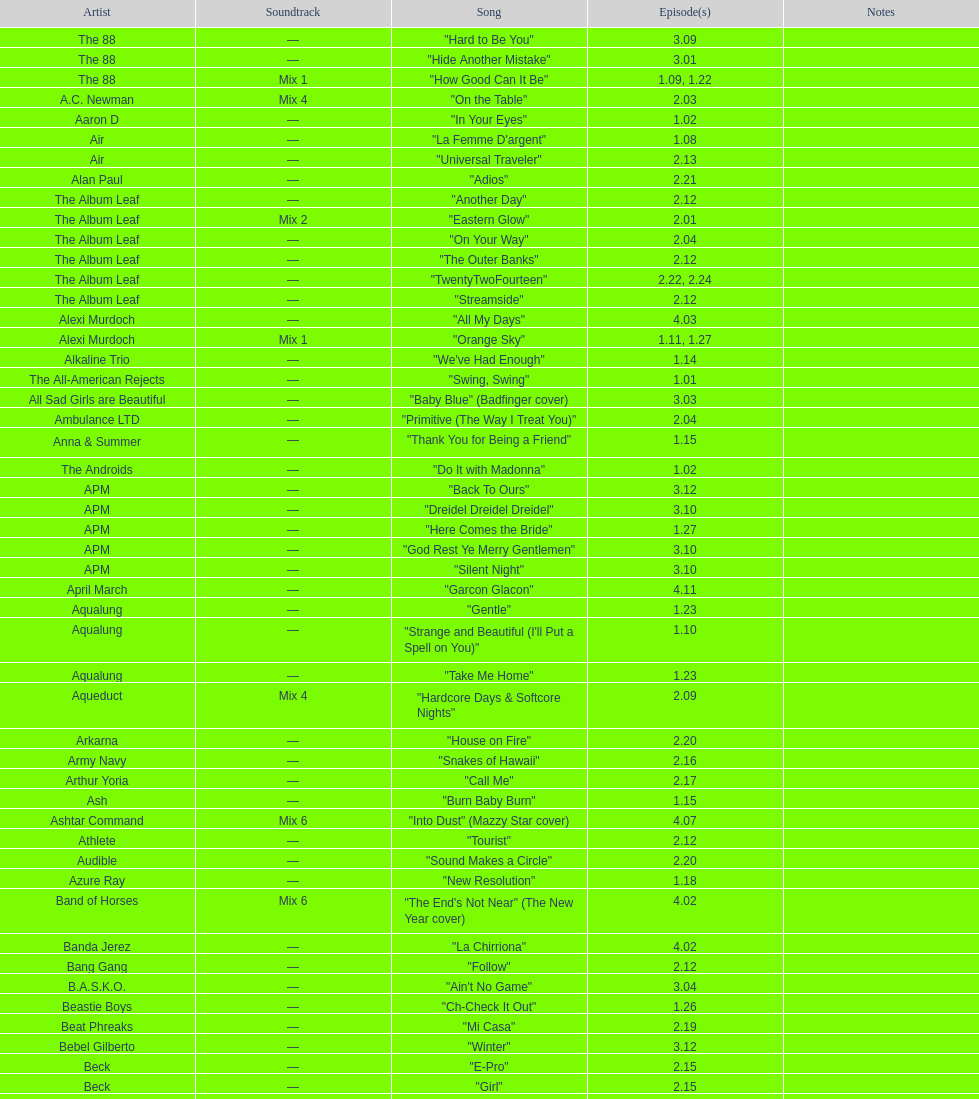How many episodes are below 2.00? 27. 